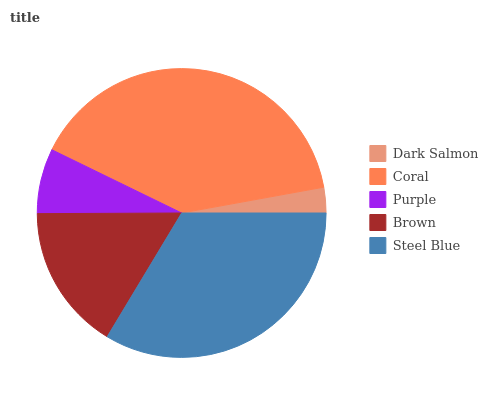Is Dark Salmon the minimum?
Answer yes or no. Yes. Is Coral the maximum?
Answer yes or no. Yes. Is Purple the minimum?
Answer yes or no. No. Is Purple the maximum?
Answer yes or no. No. Is Coral greater than Purple?
Answer yes or no. Yes. Is Purple less than Coral?
Answer yes or no. Yes. Is Purple greater than Coral?
Answer yes or no. No. Is Coral less than Purple?
Answer yes or no. No. Is Brown the high median?
Answer yes or no. Yes. Is Brown the low median?
Answer yes or no. Yes. Is Dark Salmon the high median?
Answer yes or no. No. Is Dark Salmon the low median?
Answer yes or no. No. 